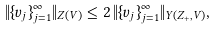Convert formula to latex. <formula><loc_0><loc_0><loc_500><loc_500>\| \{ v _ { j } \} _ { j = 1 } ^ { \infty } \| _ { Z ( V ) } \leq 2 \, \| \{ v _ { j } \} _ { j = 1 } ^ { \infty } \| _ { Y ( { Z } _ { + } , V ) } ,</formula> 